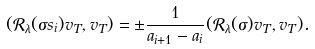Convert formula to latex. <formula><loc_0><loc_0><loc_500><loc_500>( \mathcal { R } _ { \lambda } ( \sigma s _ { i } ) v _ { T } , v _ { T } ) = \pm \frac { 1 } { a _ { i + 1 } - a _ { i } } ( \mathcal { R } _ { \lambda } ( \sigma ) v _ { T } , v _ { T } ) .</formula> 